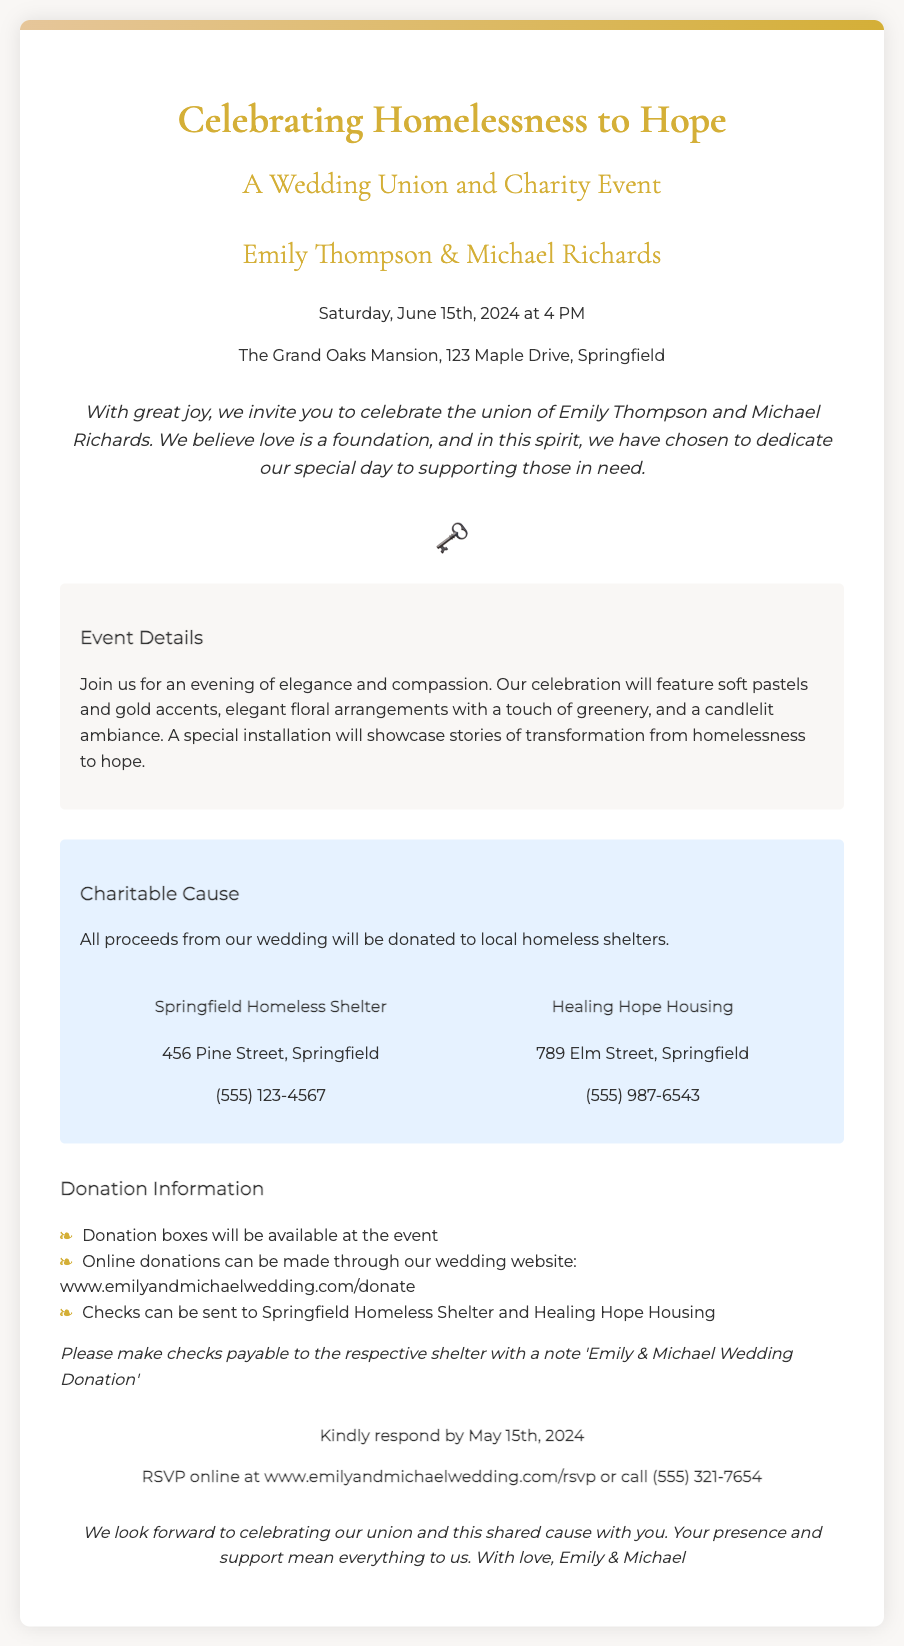What are the names of the couple getting married? The invitation explicitly states the names of the couple in the header section.
Answer: Emily Thompson & Michael Richards What is the date of the wedding? The date is clearly mentioned in the event details section of the invitation.
Answer: Saturday, June 15th, 2024 Where is the wedding taking place? The location is provided in the header section of the invitation.
Answer: The Grand Oaks Mansion, 123 Maple Drive, Springfield What is the theme of the wedding? The theme is reflected in the title and introduction of the invitation.
Answer: Celebrating Homelessness to Hope Which shelters will benefit from the donations? The invitation lists the names and addresses of the shelters in the charity info section.
Answer: Springfield Homeless Shelter and Healing Hope Housing What is the RSVP deadline? The RSVP deadline is clearly indicated in the RSVP section of the invitation.
Answer: May 15th, 2024 What kind of ambiance will the wedding feature? The ambiance is described in the details section of the invitation.
Answer: Elegant floral arrangements with a touch of greenery, and a candlelit ambiance How can guests donate? The donation methods are outlined in the donation information section.
Answer: Donation boxes, online donations, checks What symbol is used in the invitation? The symbol included in the invitation is mentioned in the key symbol section.
Answer: 🗝️ 